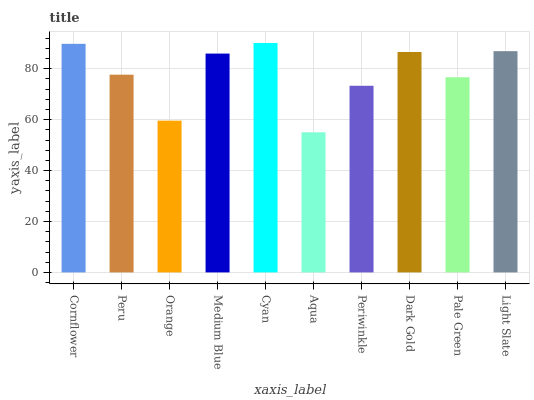Is Peru the minimum?
Answer yes or no. No. Is Peru the maximum?
Answer yes or no. No. Is Cornflower greater than Peru?
Answer yes or no. Yes. Is Peru less than Cornflower?
Answer yes or no. Yes. Is Peru greater than Cornflower?
Answer yes or no. No. Is Cornflower less than Peru?
Answer yes or no. No. Is Medium Blue the high median?
Answer yes or no. Yes. Is Peru the low median?
Answer yes or no. Yes. Is Cornflower the high median?
Answer yes or no. No. Is Aqua the low median?
Answer yes or no. No. 